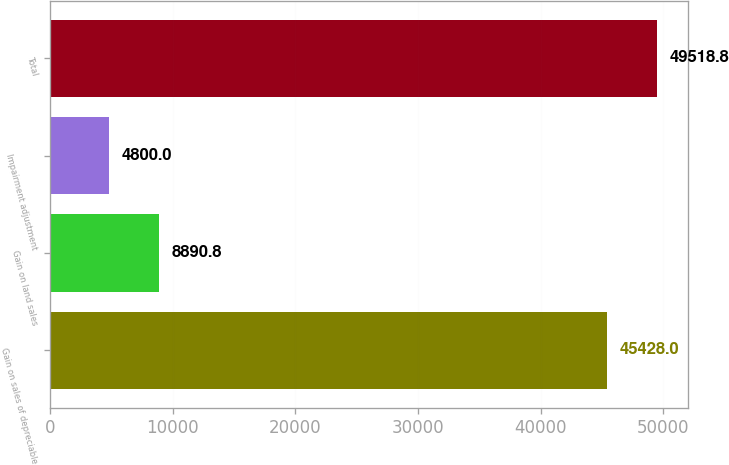<chart> <loc_0><loc_0><loc_500><loc_500><bar_chart><fcel>Gain on sales of depreciable<fcel>Gain on land sales<fcel>Impairment adjustment<fcel>Total<nl><fcel>45428<fcel>8890.8<fcel>4800<fcel>49518.8<nl></chart> 